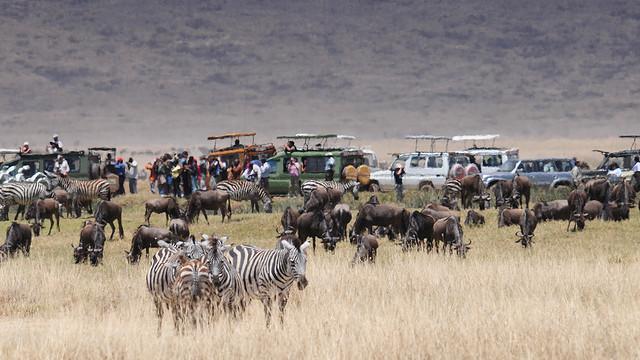How many vehicles are in the field?
Give a very brief answer. 7. How many zebras are there?
Give a very brief answer. 2. How many trucks are there?
Give a very brief answer. 3. How many beds are in the bedroom?
Give a very brief answer. 0. 